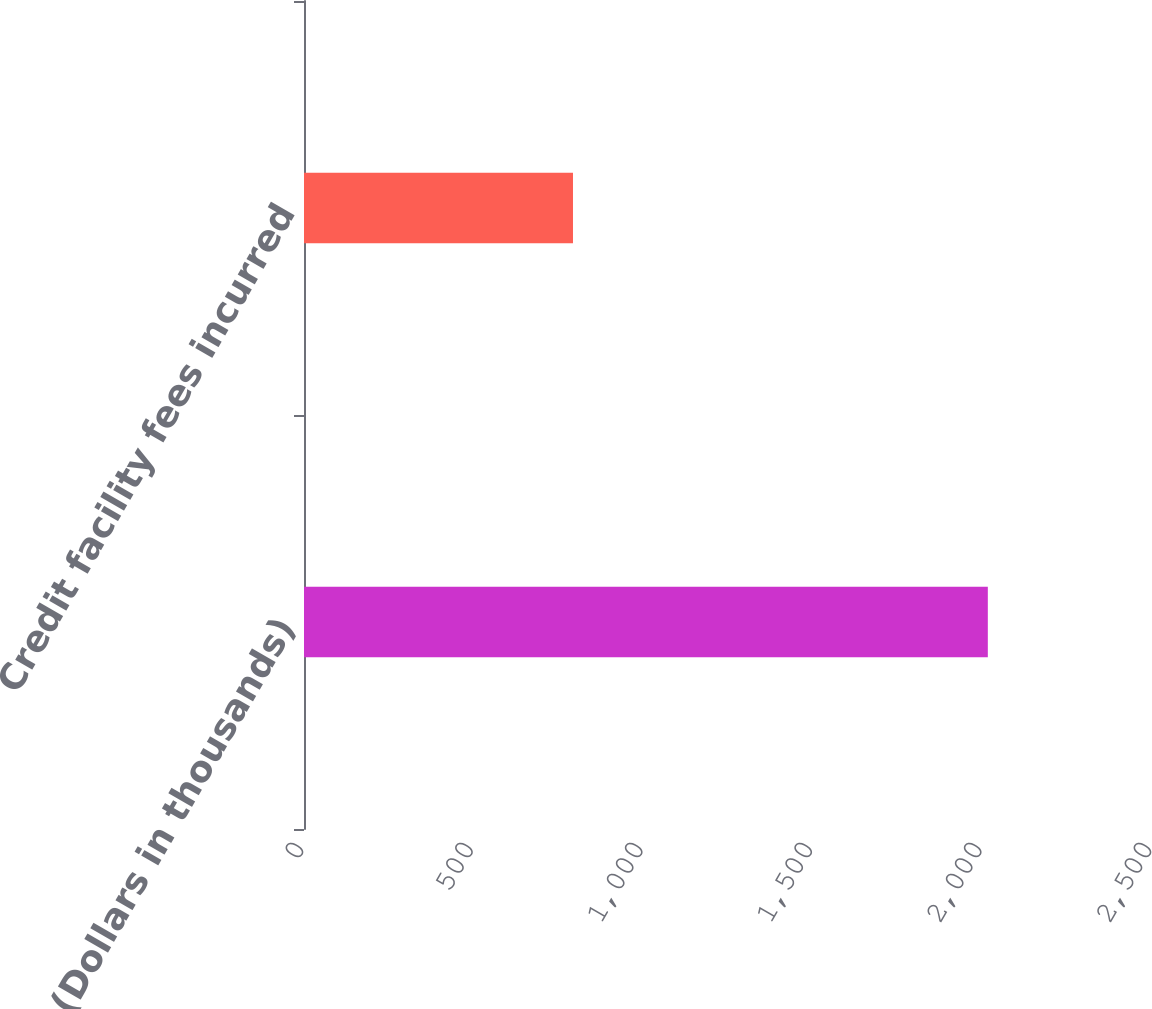<chart> <loc_0><loc_0><loc_500><loc_500><bar_chart><fcel>(Dollars in thousands)<fcel>Credit facility fees incurred<nl><fcel>2016<fcel>793<nl></chart> 